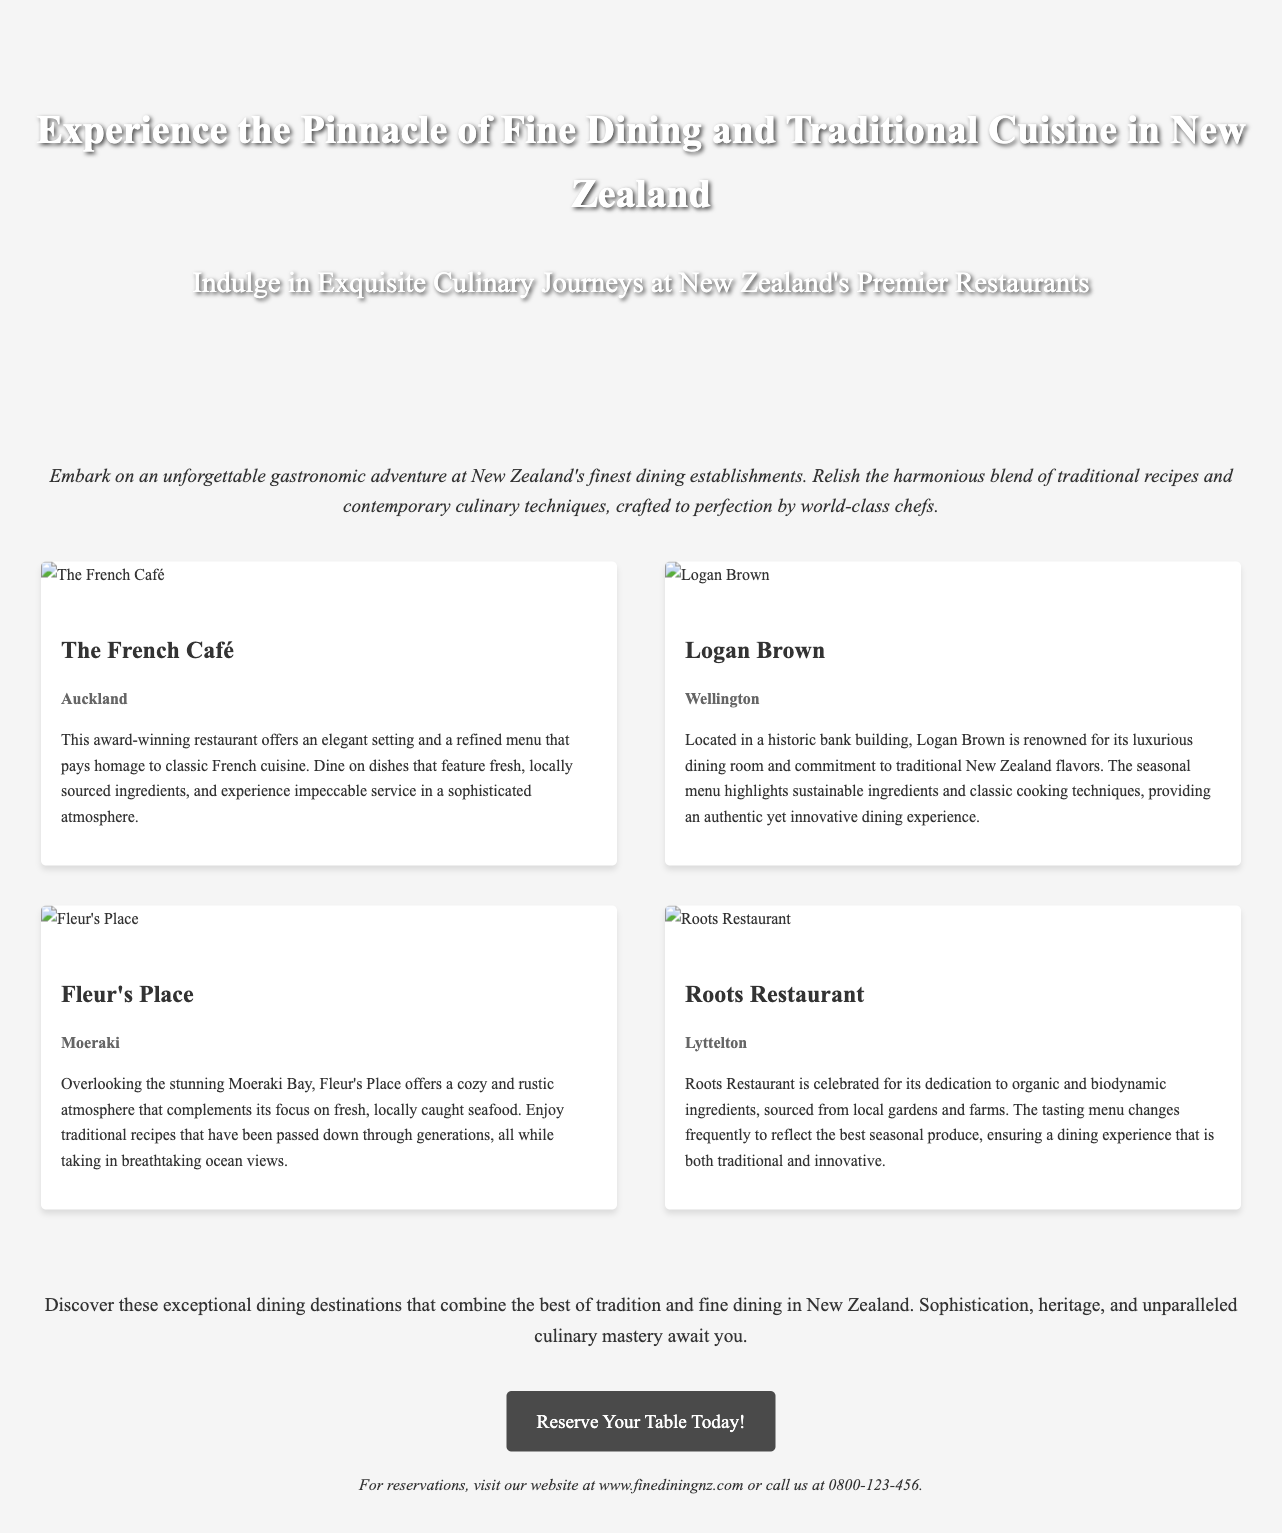What is the title of the advertisement? The title of the advertisement is prominently displayed in the header, stating the purpose and appeal of the content.
Answer: Experience the Pinnacle of Fine Dining and Traditional Cuisine in New Zealand How many restaurants are featured in the document? The document lists a total of four distinct restaurants along with their descriptions.
Answer: Four Which restaurant is located in Auckland? The information provided clearly identifies the location of each restaurant, specifying the city each one is situated in.
Answer: The French Café What type of cuisine does Logan Brown focus on? The description of Logan Brown mentions its commitment to specific culinary styles and influences.
Answer: Traditional New Zealand flavors What is the conclusion of the advertisement? The concluding statement summarizes the overall theme and invites potential customers to explore the listed dining options.
Answer: Discover these exceptional dining destinations that combine the best of tradition and fine dining in New Zealand What is the call to action in the document? The document includes a specific and inviting phrase encouraging readers to take a particular action after reading.
Answer: Reserve Your Table Today! In which city is Fleur's Place located? The location of Fleur's Place is explicitly mentioned alongside its description in the document.
Answer: Moeraki 